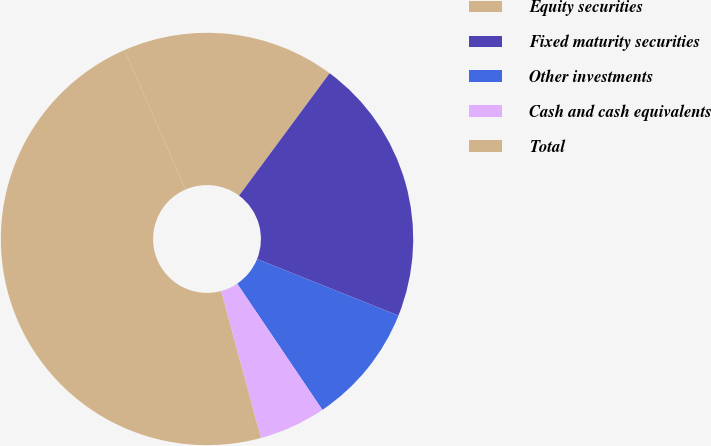<chart> <loc_0><loc_0><loc_500><loc_500><pie_chart><fcel>Equity securities<fcel>Fixed maturity securities<fcel>Other investments<fcel>Cash and cash equivalents<fcel>Total<nl><fcel>16.68%<fcel>20.92%<fcel>9.49%<fcel>5.24%<fcel>47.66%<nl></chart> 